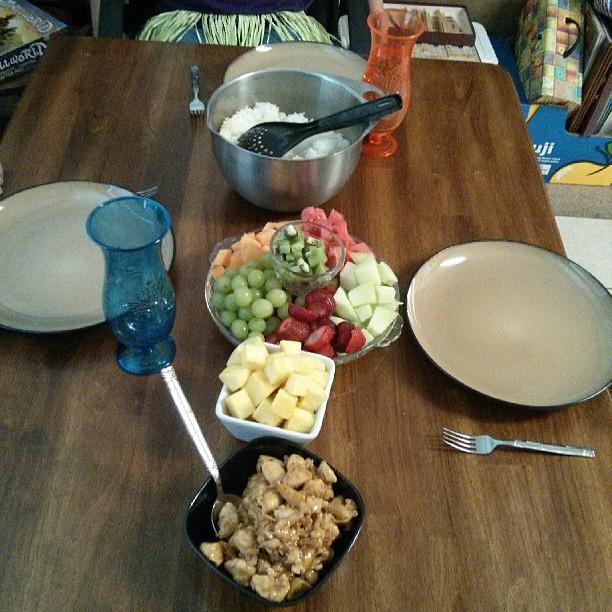What color is the vase on the left?
Answer briefly. Blue. Of what material is the bowl?
Answer briefly. Ceramic. What material is the table?
Give a very brief answer. Wood. How many forks?
Answer briefly. 2. 